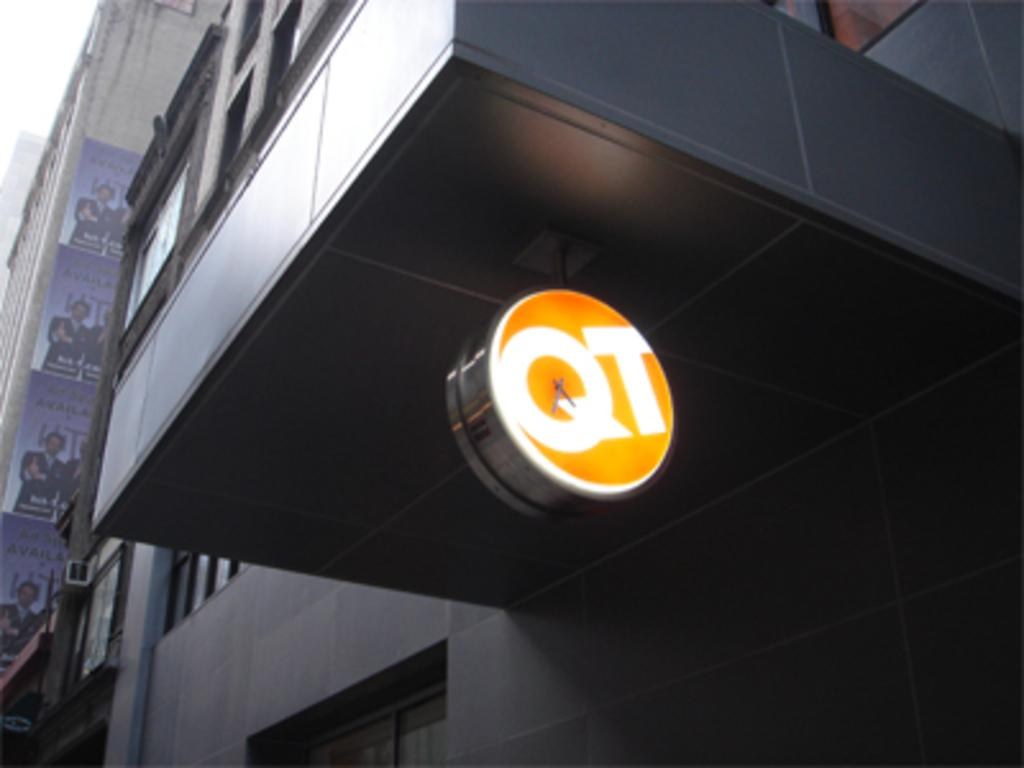What type of structure is present in the image? There is a building in the image. What feature of the building can be seen in the image? The building contains a clock. How many trees are visible in the image? There are no trees visible in the image; it only features a building with a clock. Is there a basketball court in the image? There is no basketball court present in the image. 